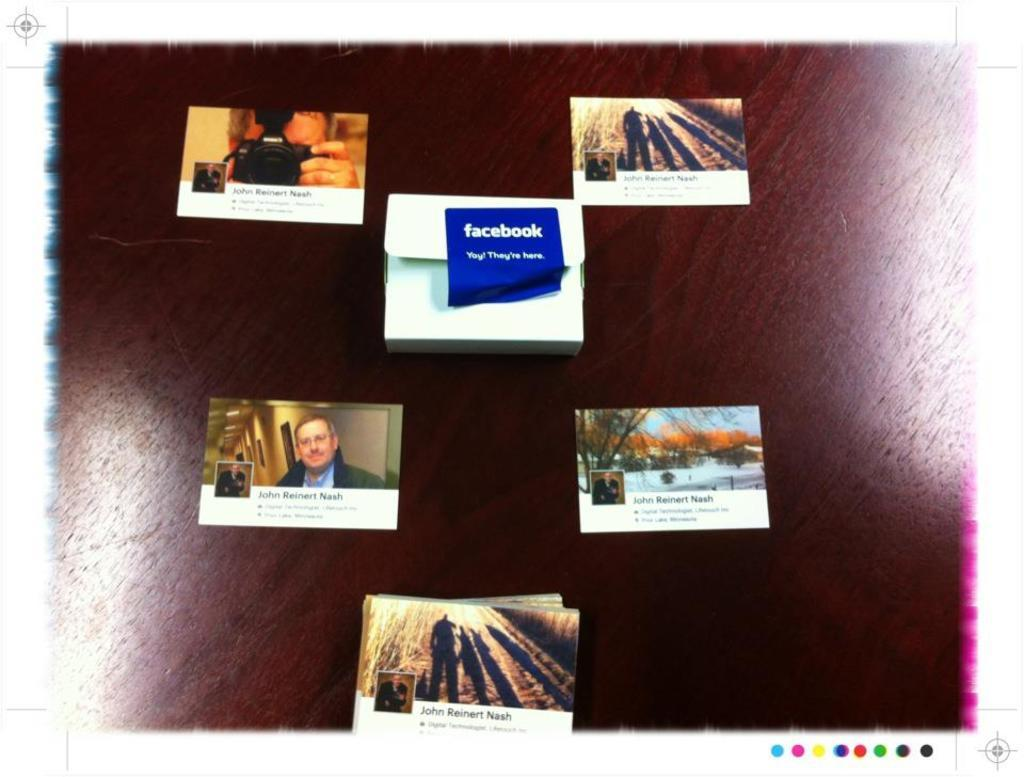<image>
Describe the image concisely. A screen with several windows showing including a Facebook one. 